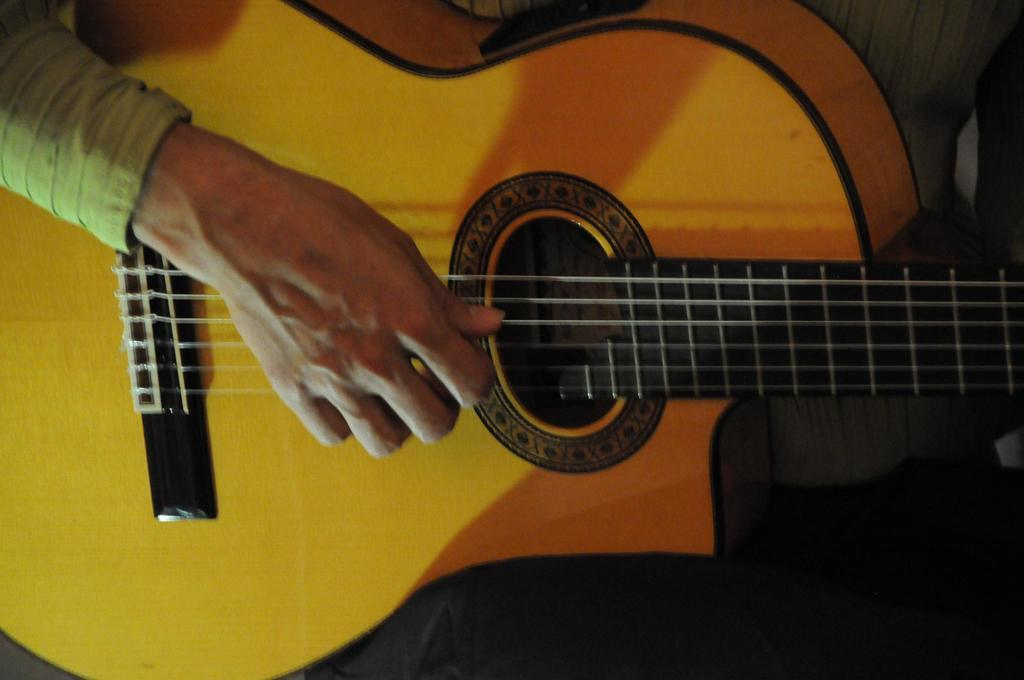What musical instrument is present in the image? There is a guitar in the image. What is the person in the image doing with the guitar? A person's hand is playing the strings of the guitar. What type of bun is the person holding while playing the guitar? There is no bun present in the image; the person is only playing the guitar. 